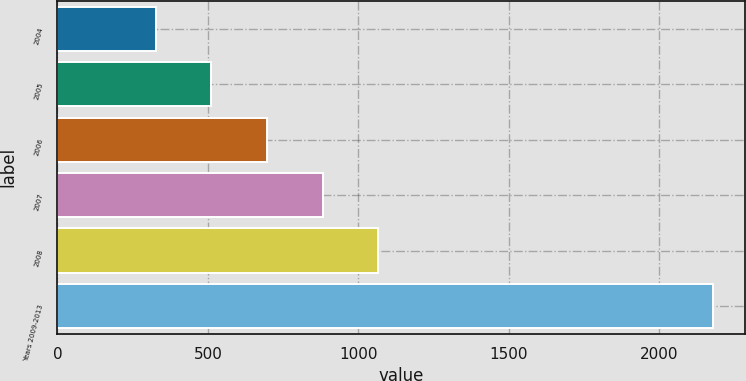Convert chart. <chart><loc_0><loc_0><loc_500><loc_500><bar_chart><fcel>2004<fcel>2005<fcel>2006<fcel>2007<fcel>2008<fcel>Years 2009-2013<nl><fcel>326<fcel>511.1<fcel>696.2<fcel>881.3<fcel>1066.4<fcel>2177<nl></chart> 